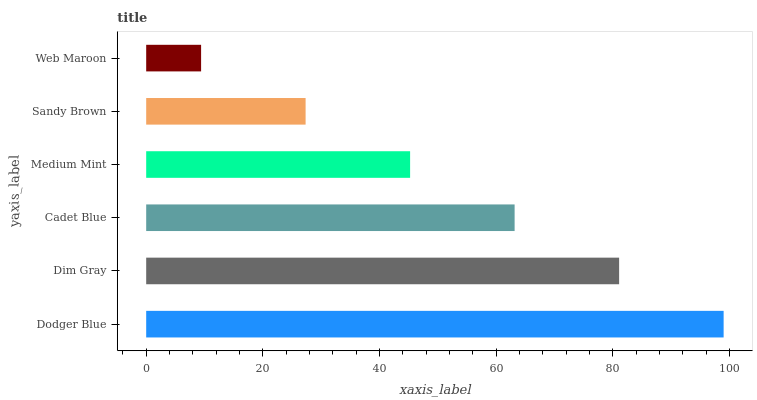Is Web Maroon the minimum?
Answer yes or no. Yes. Is Dodger Blue the maximum?
Answer yes or no. Yes. Is Dim Gray the minimum?
Answer yes or no. No. Is Dim Gray the maximum?
Answer yes or no. No. Is Dodger Blue greater than Dim Gray?
Answer yes or no. Yes. Is Dim Gray less than Dodger Blue?
Answer yes or no. Yes. Is Dim Gray greater than Dodger Blue?
Answer yes or no. No. Is Dodger Blue less than Dim Gray?
Answer yes or no. No. Is Cadet Blue the high median?
Answer yes or no. Yes. Is Medium Mint the low median?
Answer yes or no. Yes. Is Dim Gray the high median?
Answer yes or no. No. Is Dodger Blue the low median?
Answer yes or no. No. 